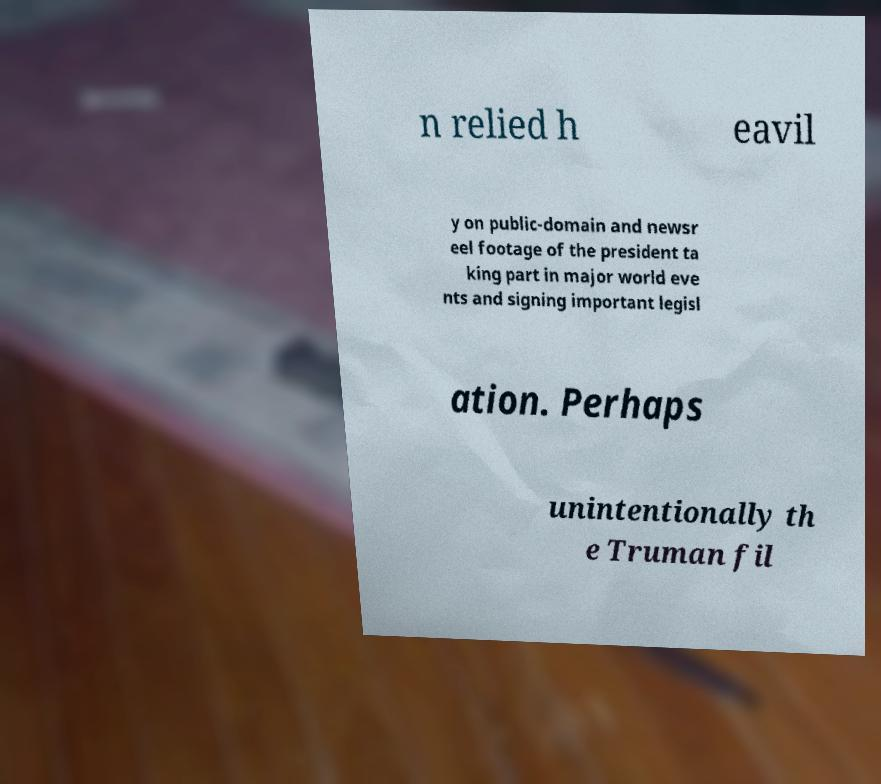Please read and relay the text visible in this image. What does it say? n relied h eavil y on public-domain and newsr eel footage of the president ta king part in major world eve nts and signing important legisl ation. Perhaps unintentionally th e Truman fil 